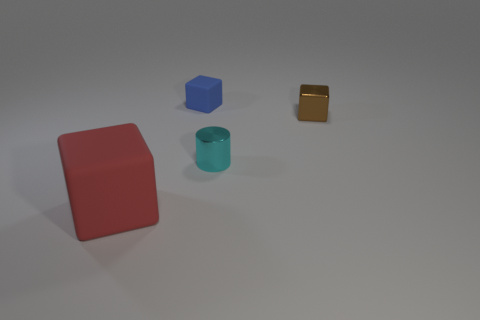Add 4 brown metallic cubes. How many objects exist? 8 Subtract all cylinders. How many objects are left? 3 Subtract 1 red blocks. How many objects are left? 3 Subtract all tiny red things. Subtract all tiny brown cubes. How many objects are left? 3 Add 2 rubber objects. How many rubber objects are left? 4 Add 1 gray rubber objects. How many gray rubber objects exist? 1 